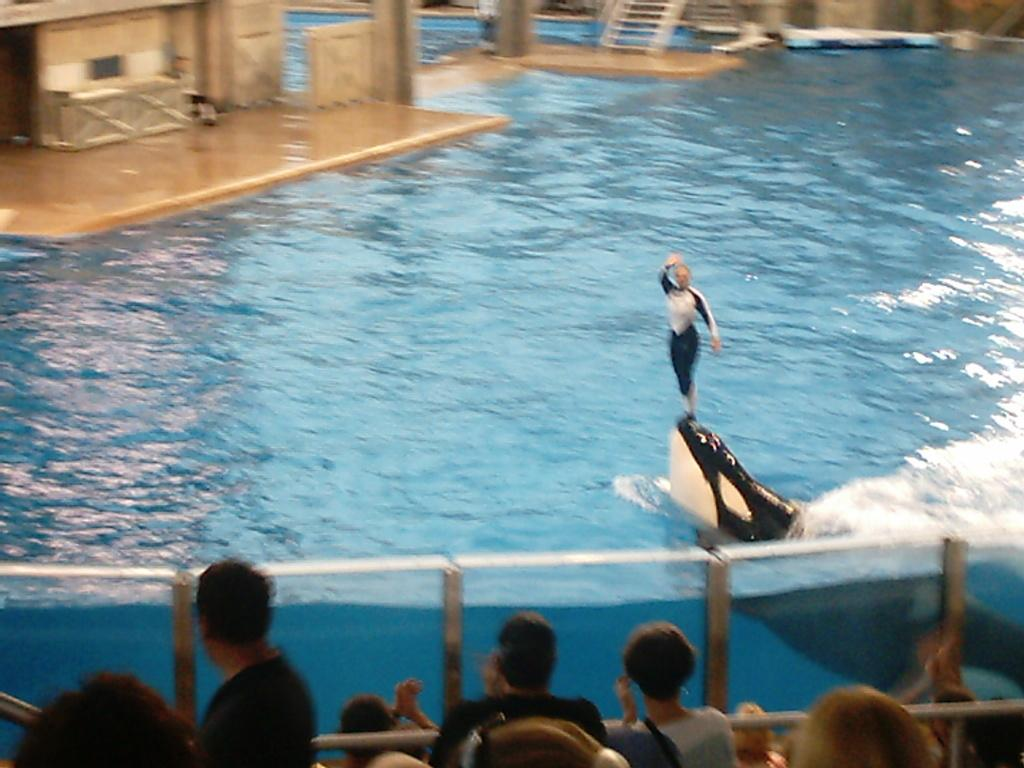What is the person in the image doing? The person in the image is standing on a dolphin. What is the setting of the image? There is water visible in the image. Are there any other people present in the image? Yes, there are people watching the person on the dolphin. What type of parent is the donkey in the image? There is no donkey or parent present in the image. 